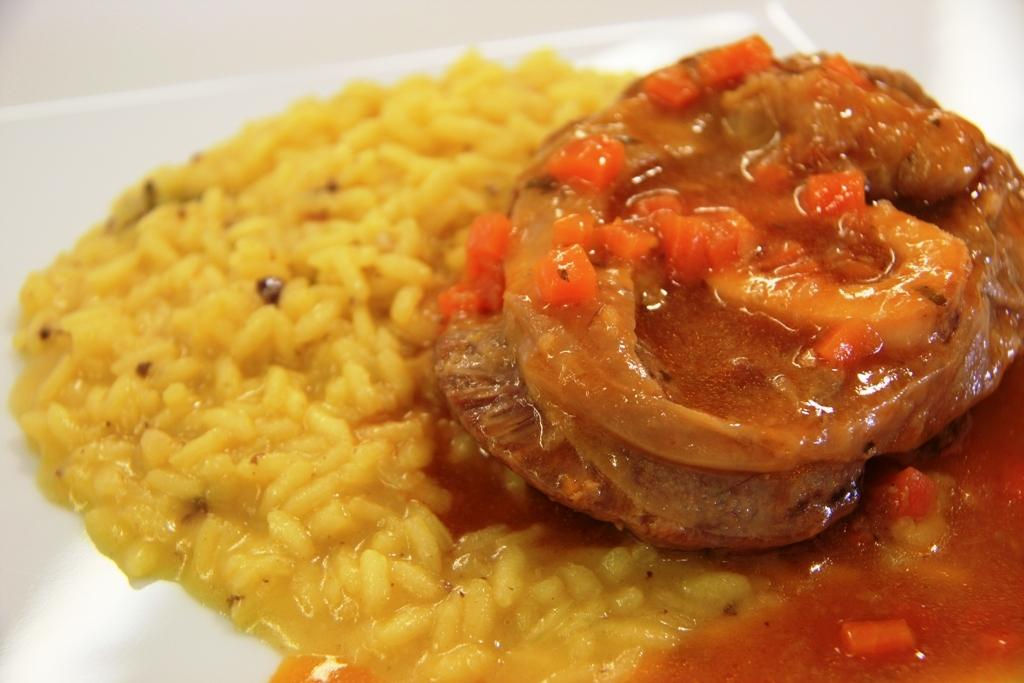What can be seen in the image? There are food items in the image. Where are the food items located? The food items are placed on a surface. What type of elbow is visible on the stage in the image? There is no elbow or stage present in the image; it only features food items placed on a surface. 